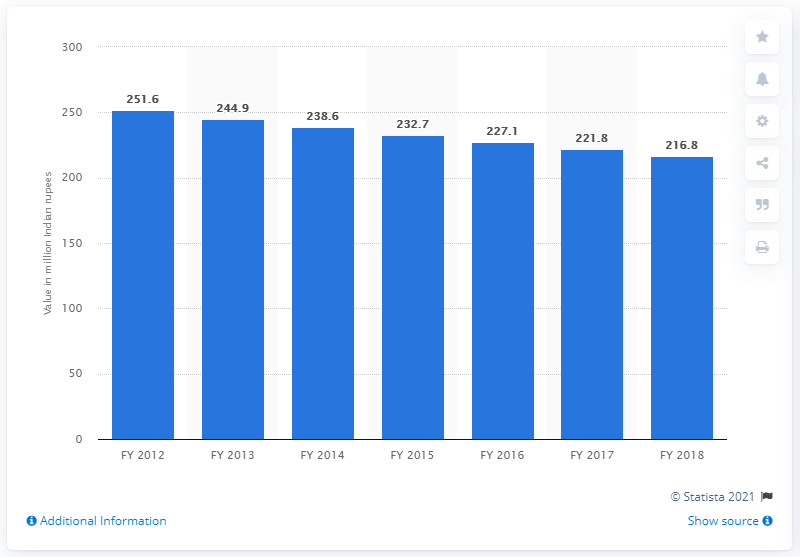Mention a couple of crucial points in this snapshot. In the fiscal year 2018, the contribution of dung from Delhi to the Indian economy was 216.8 rupees. 